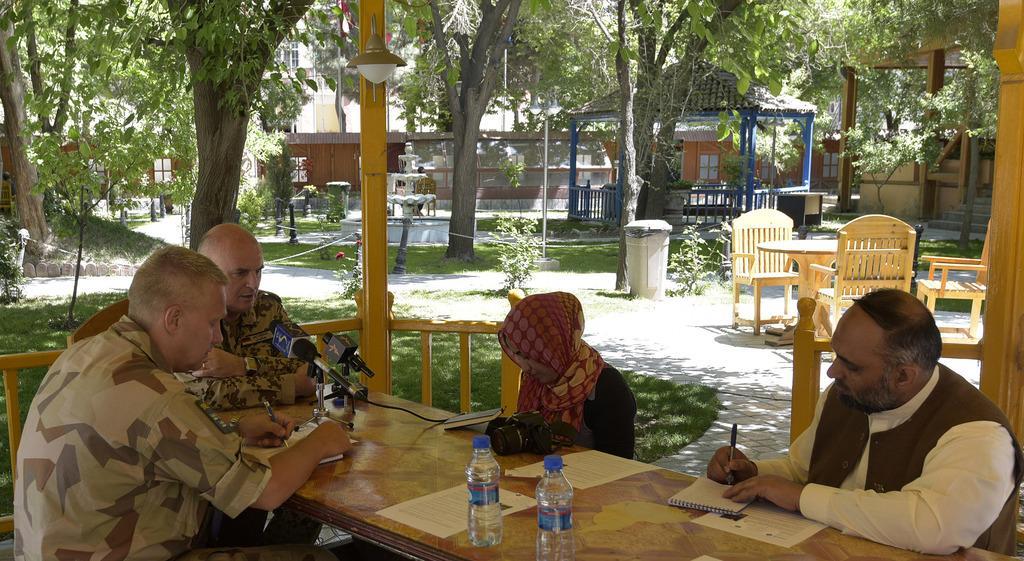How would you summarize this image in a sentence or two? On the background we can see building and trees. This is a hut. We can see table and few empty chairs. This is a trash can. These are plants. Here we can see few persons sitting on chairs in front of a table and on the table we can see my, camera, bottles, book, paper. These two persons holding pen in their hands and writing in a book. 